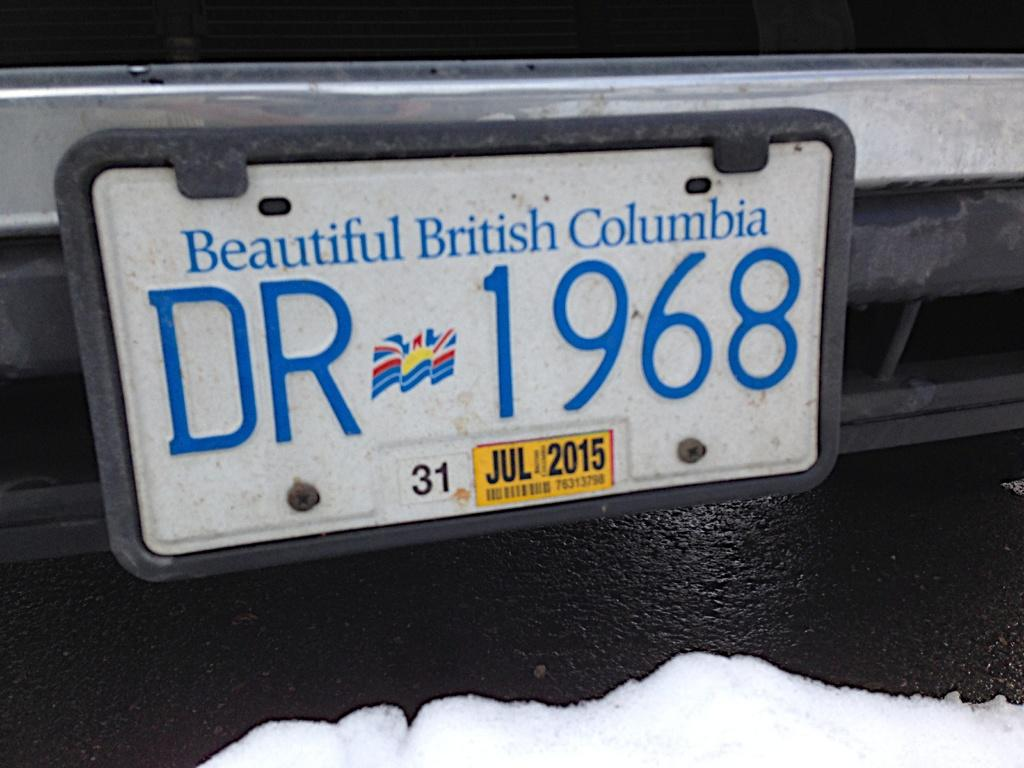<image>
Offer a succinct explanation of the picture presented. A British Columbia license plate has a July 2015 sticker at the bottom. 